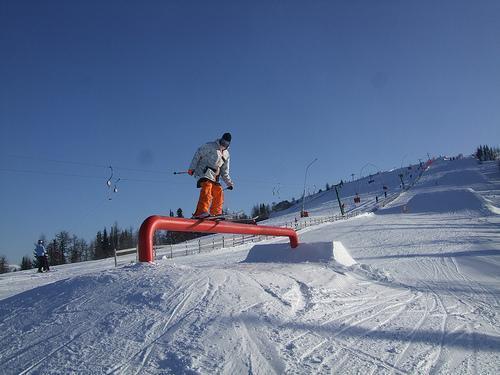How many people are there?
Give a very brief answer. 1. 